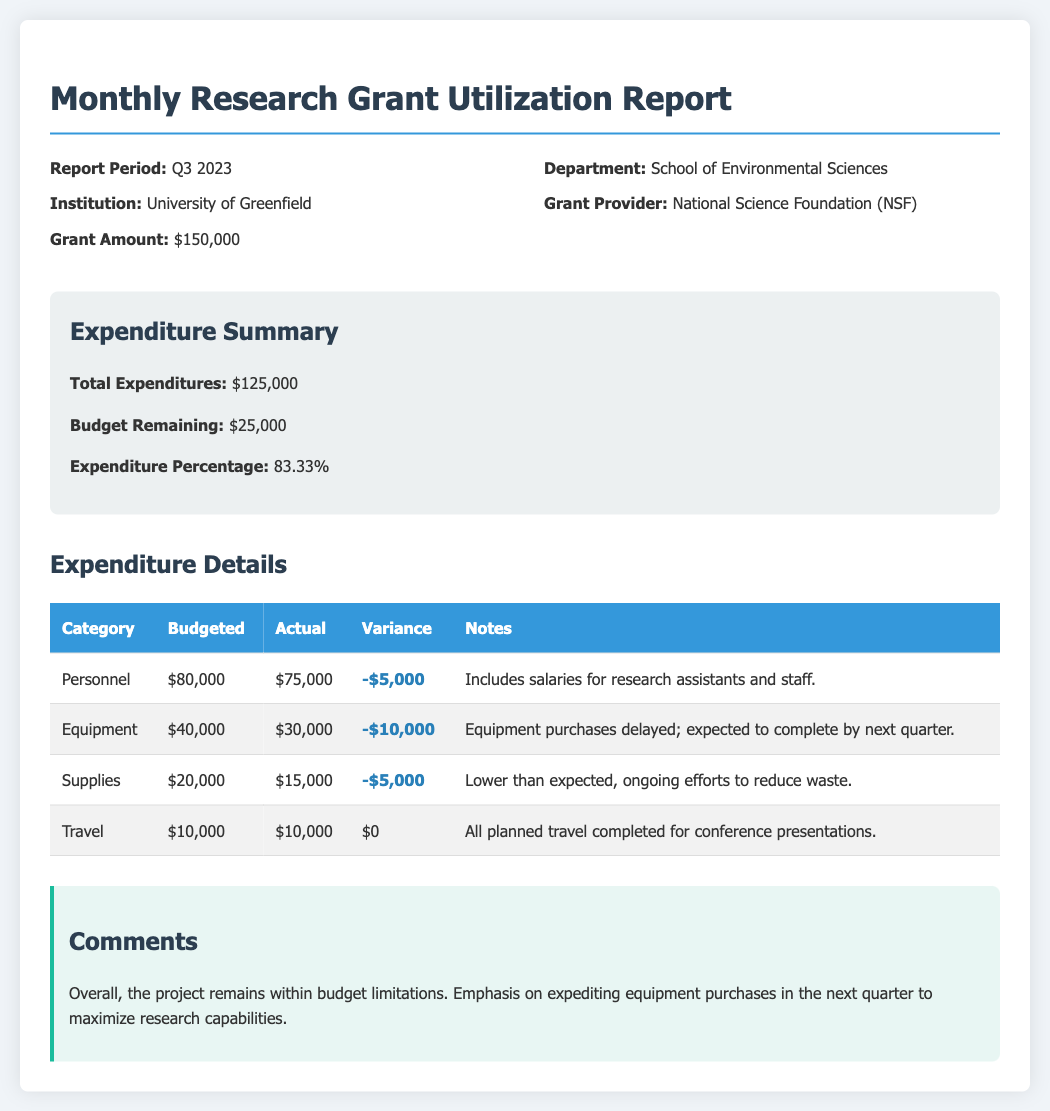What is the report period? The report period, stated in the document, specifies the time frame for the report, which is Q3 2023.
Answer: Q3 2023 What is the total expenditure? The total expenditure is mentioned in the summary section of the document, which states it as $125,000.
Answer: $125,000 How much is the budget remaining? The budget remaining is derived from the summary section, which indicates that there is $25,000 left in the budget.
Answer: $25,000 What is the expenditure percentage? The expenditure percentage is calculated based on total expenditures compared to the budget, which is stated as 83.33%.
Answer: 83.33% What is the actual expenditure for Equipment? The actual expenditure for Equipment is detailed in the expenditures table, which shows it as $30,000.
Answer: $30,000 What is the variance for Personnel? The variance for Personnel is noted in the expenditure details table, reflecting a negative variance of $5,000.
Answer: -$5,000 What is the primary comment regarding overall expenditure? The overall expenditure comment is found in the comments section, emphasizing that the project remains within budget limitations.
Answer: within budget limitations Which grant provider is listed in the report? The grant provider is specifically mentioned in the header information, which identifies it as the National Science Foundation (NSF).
Answer: National Science Foundation (NSF) How much was budgeted for Supplies? The budgeted amount for Supplies is provided in the expenditure details table, which states it as $20,000.
Answer: $20,000 